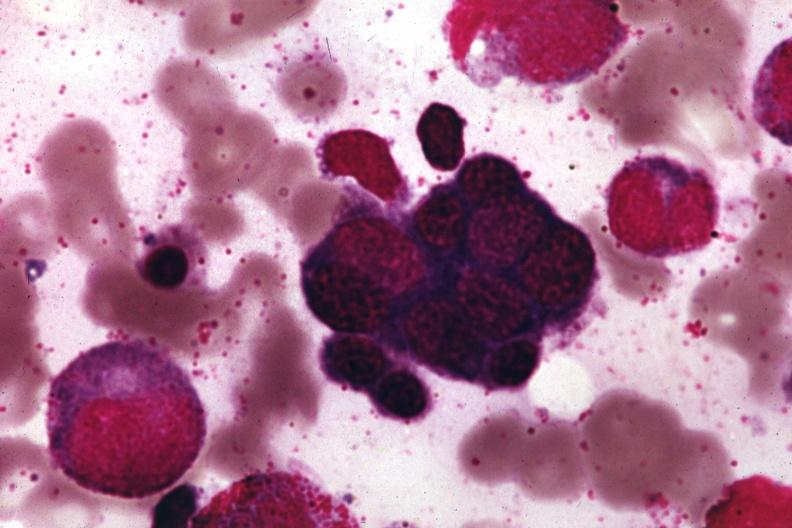what does this image show?
Answer the question using a single word or phrase. Wrights 